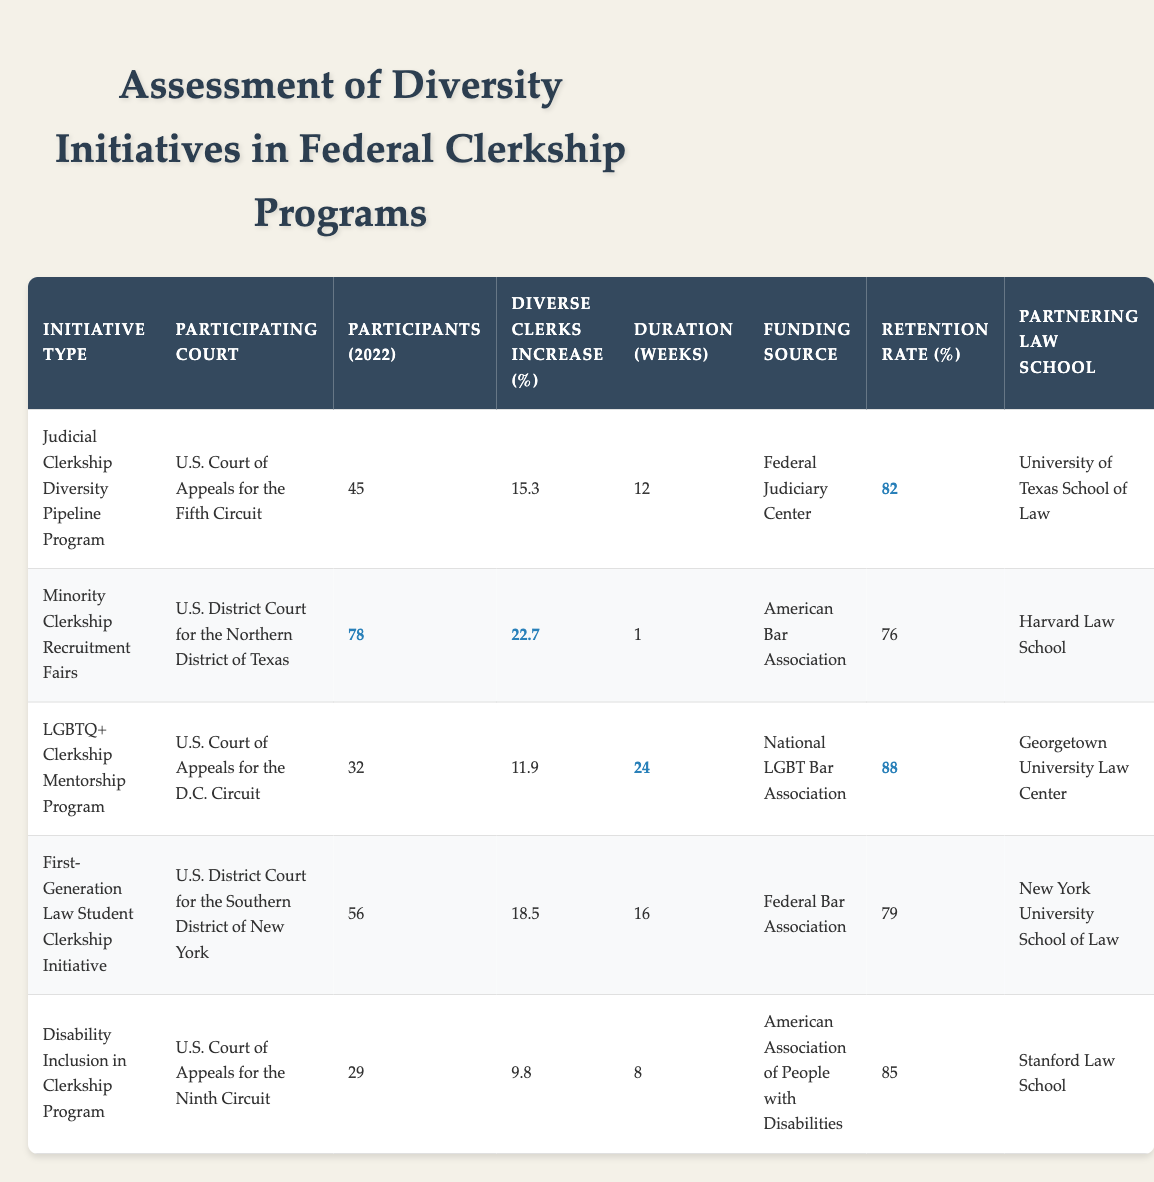What is the participation count for the Judicial Clerkship Diversity Pipeline Program? From the table, in the row under the Judicial Clerkship Diversity Pipeline Program, the number of participants listed is 45.
Answer: 45 Which initiative had the highest percentage increase in diverse clerks from 2020 to 2022? The table shows that the Minority Clerkship Recruitment Fairs had a percentage increase of 22.7%, which is higher than the others.
Answer: 22.7% What is the average retention rate of diverse clerks across all initiatives? To find the average, I will sum the retention rates (82 + 76 + 88 + 79 + 85 = 410) and divide by the number of initiatives (5). The average retention rate is 410 / 5 = 82.
Answer: 82 Did the LGBTQ+ Clerkship Mentorship Program have a lower retention rate than the Minority Clerkship Recruitment Fairs? The retention rate for the LGBTQ+ Clerkship Mentorship Program is 88%, which is higher than the 76% of the Minority Clerkship Recruitment Fairs. Thus, it did not have a lower retention rate.
Answer: No What is the total number of participants in all initiatives listed in the table? Summing the participants gives us (45 + 78 + 32 + 56 + 29 = 240), so the total number of participants is 240.
Answer: 240 Which diversity initiative had the longest duration, and what was its duration? Reviewing the durations in the table, the LGBTQ+ Clerkship Mentorship Program has the longest duration at 24 weeks.
Answer: 24 weeks Is the funding source for the Disability Inclusion in Clerkship Program the same as for the Judicial Clerkship Diversity Pipeline Program? The table indicates that the Disability Inclusion in Clerkship Program is funded by the American Association of People with Disabilities, while the Judicial Clerkship Diversity Pipeline Program is funded by the Federal Judiciary Center. They are different.
Answer: No How does the retention rate of the First-Generation Law Student Clerkship Initiative compare to that of the Disability Inclusion in Clerkship Program? The retention rate for the First-Generation Law Student Clerkship Initiative is 79%, while for the Disability Inclusion in Clerkship Program, it is 85%. Thus, the rate for the Disability Inclusion is higher.
Answer: Higher Which partnering law school is associated with the Minority Clerkship Recruitment Fairs? According to the table, the Minority Clerkship Recruitment Fairs are partnered with Harvard Law School.
Answer: Harvard Law School 